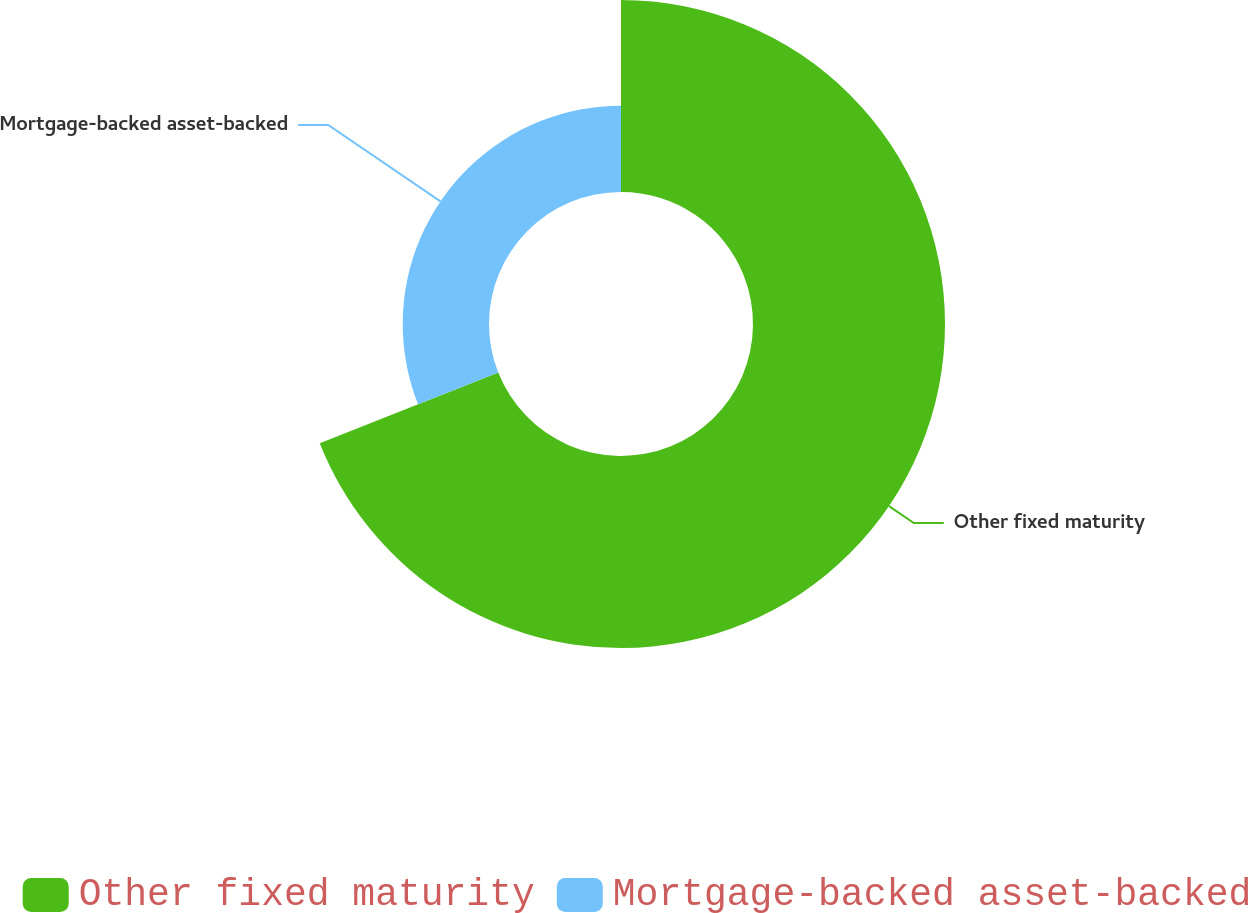Convert chart to OTSL. <chart><loc_0><loc_0><loc_500><loc_500><pie_chart><fcel>Other fixed maturity<fcel>Mortgage-backed asset-backed<nl><fcel>69.0%<fcel>31.0%<nl></chart> 